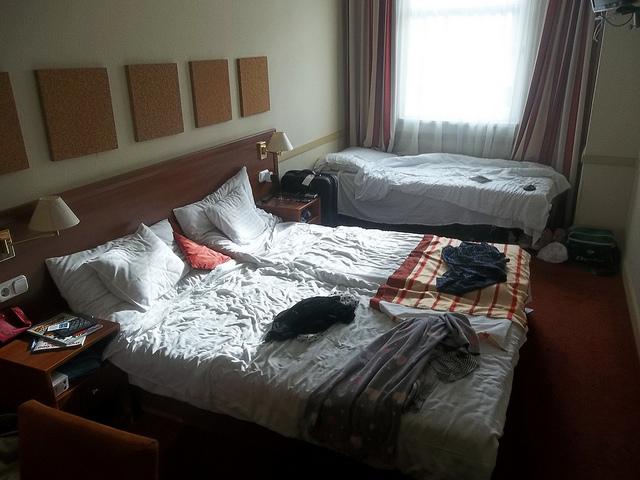What is showing in the photo?
Concise answer only. Hotel room. How many people are there?
Give a very brief answer. 0. Are the beds made?
Quick response, please. No. 